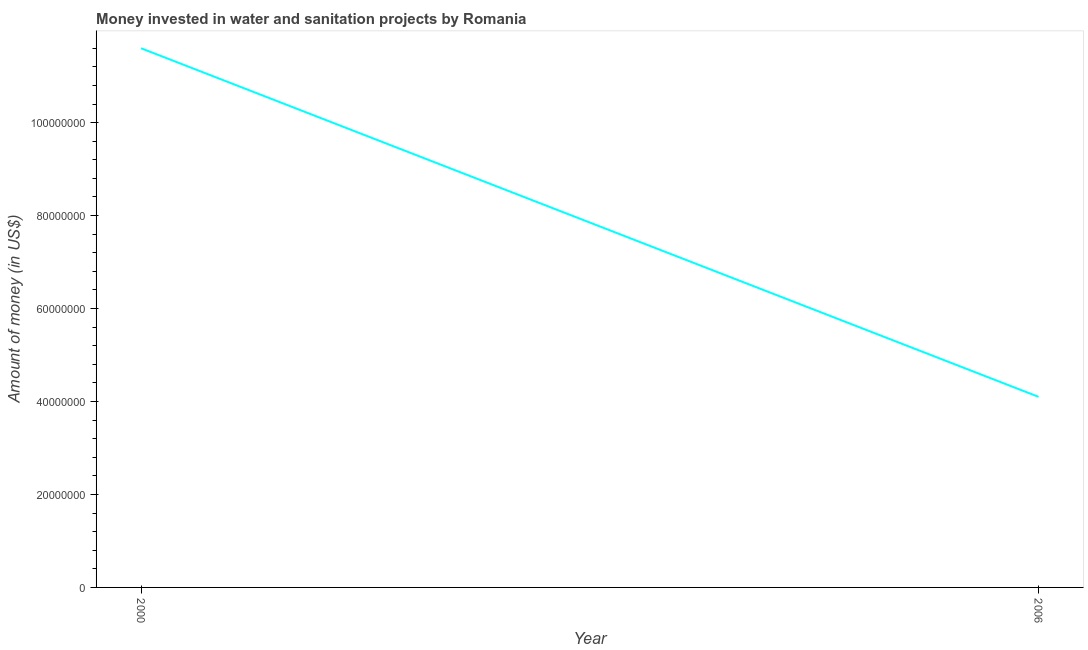What is the investment in 2006?
Make the answer very short. 4.10e+07. Across all years, what is the maximum investment?
Make the answer very short. 1.16e+08. Across all years, what is the minimum investment?
Provide a short and direct response. 4.10e+07. In which year was the investment minimum?
Offer a very short reply. 2006. What is the sum of the investment?
Make the answer very short. 1.57e+08. What is the difference between the investment in 2000 and 2006?
Offer a terse response. 7.50e+07. What is the average investment per year?
Offer a very short reply. 7.85e+07. What is the median investment?
Your answer should be compact. 7.85e+07. In how many years, is the investment greater than 8000000 US$?
Your response must be concise. 2. What is the ratio of the investment in 2000 to that in 2006?
Ensure brevity in your answer.  2.83. Is the investment in 2000 less than that in 2006?
Make the answer very short. No. Does the investment monotonically increase over the years?
Ensure brevity in your answer.  No. Does the graph contain grids?
Your response must be concise. No. What is the title of the graph?
Offer a terse response. Money invested in water and sanitation projects by Romania. What is the label or title of the X-axis?
Offer a very short reply. Year. What is the label or title of the Y-axis?
Offer a terse response. Amount of money (in US$). What is the Amount of money (in US$) of 2000?
Provide a succinct answer. 1.16e+08. What is the Amount of money (in US$) in 2006?
Give a very brief answer. 4.10e+07. What is the difference between the Amount of money (in US$) in 2000 and 2006?
Ensure brevity in your answer.  7.50e+07. What is the ratio of the Amount of money (in US$) in 2000 to that in 2006?
Ensure brevity in your answer.  2.83. 